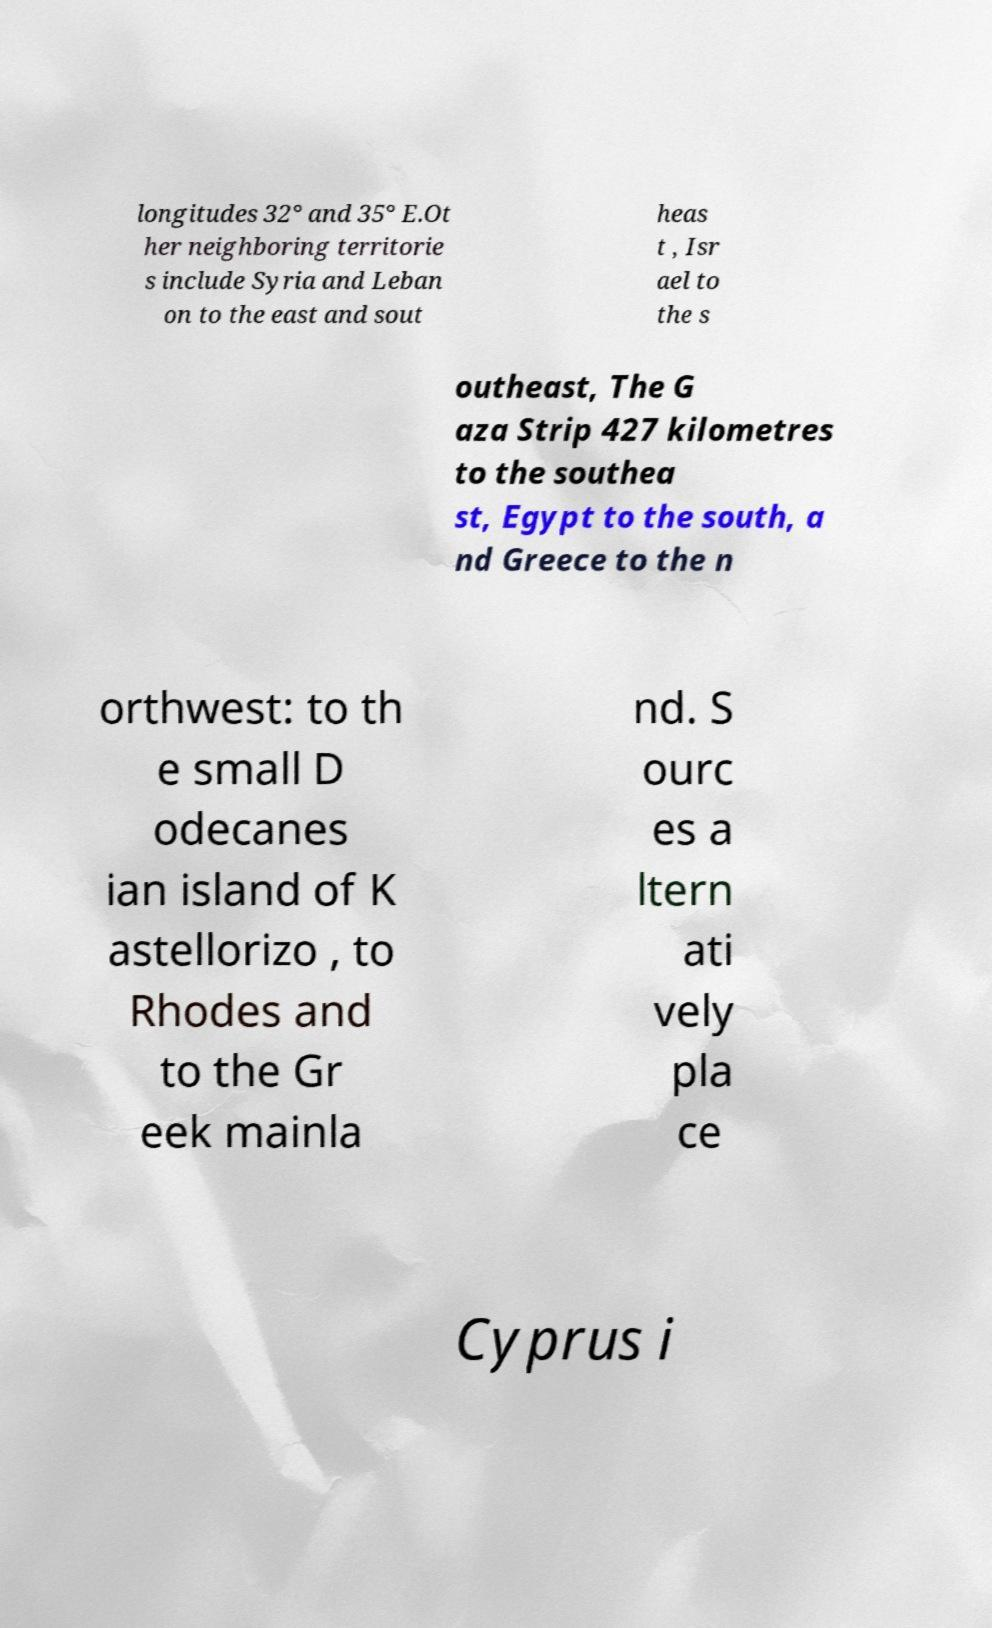There's text embedded in this image that I need extracted. Can you transcribe it verbatim? longitudes 32° and 35° E.Ot her neighboring territorie s include Syria and Leban on to the east and sout heas t , Isr ael to the s outheast, The G aza Strip 427 kilometres to the southea st, Egypt to the south, a nd Greece to the n orthwest: to th e small D odecanes ian island of K astellorizo , to Rhodes and to the Gr eek mainla nd. S ourc es a ltern ati vely pla ce Cyprus i 